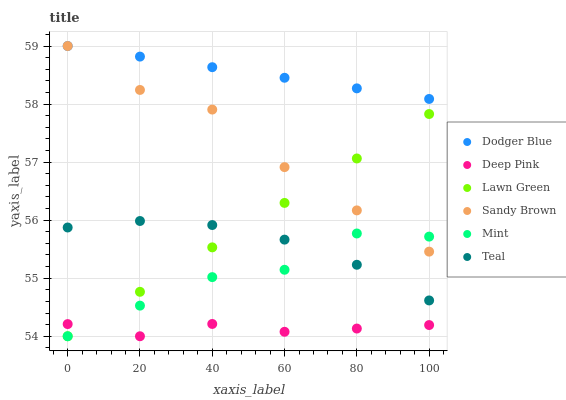Does Deep Pink have the minimum area under the curve?
Answer yes or no. Yes. Does Dodger Blue have the maximum area under the curve?
Answer yes or no. Yes. Does Sandy Brown have the minimum area under the curve?
Answer yes or no. No. Does Sandy Brown have the maximum area under the curve?
Answer yes or no. No. Is Lawn Green the smoothest?
Answer yes or no. Yes. Is Mint the roughest?
Answer yes or no. Yes. Is Deep Pink the smoothest?
Answer yes or no. No. Is Deep Pink the roughest?
Answer yes or no. No. Does Lawn Green have the lowest value?
Answer yes or no. Yes. Does Sandy Brown have the lowest value?
Answer yes or no. No. Does Dodger Blue have the highest value?
Answer yes or no. Yes. Does Deep Pink have the highest value?
Answer yes or no. No. Is Lawn Green less than Dodger Blue?
Answer yes or no. Yes. Is Dodger Blue greater than Deep Pink?
Answer yes or no. Yes. Does Sandy Brown intersect Lawn Green?
Answer yes or no. Yes. Is Sandy Brown less than Lawn Green?
Answer yes or no. No. Is Sandy Brown greater than Lawn Green?
Answer yes or no. No. Does Lawn Green intersect Dodger Blue?
Answer yes or no. No. 